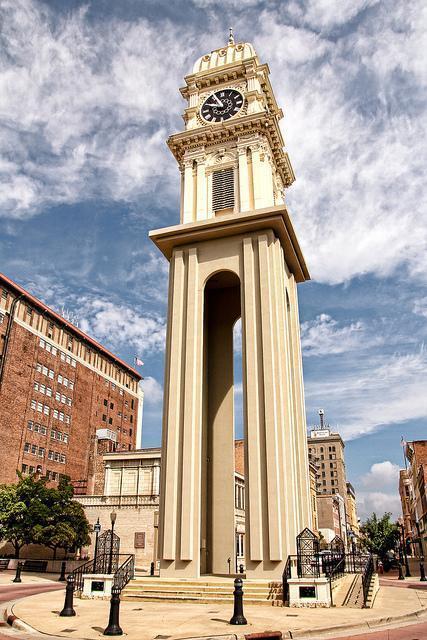How many dogs are on he bench in this image?
Give a very brief answer. 0. 